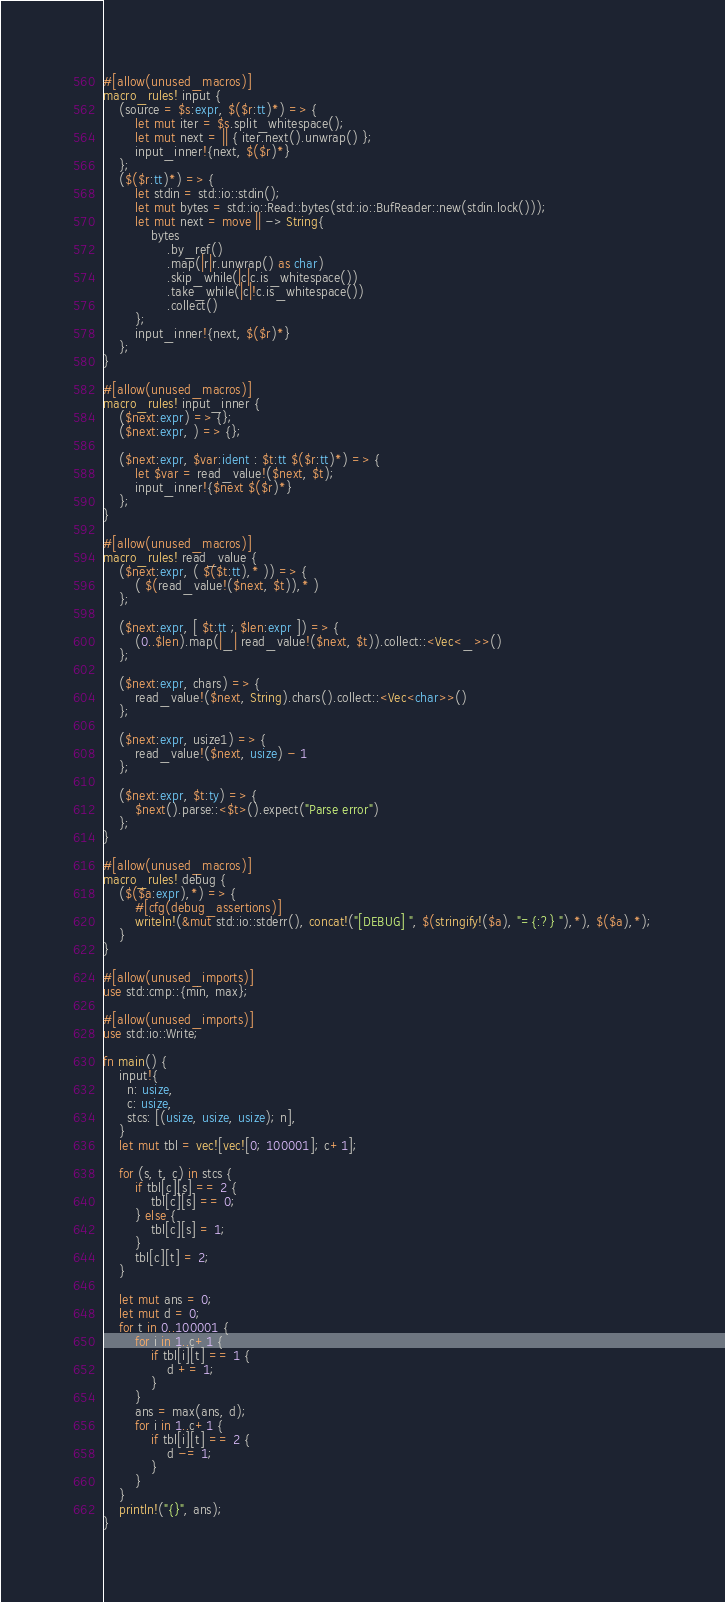Convert code to text. <code><loc_0><loc_0><loc_500><loc_500><_Rust_>#[allow(unused_macros)]
macro_rules! input {
    (source = $s:expr, $($r:tt)*) => {
        let mut iter = $s.split_whitespace();
        let mut next = || { iter.next().unwrap() };
        input_inner!{next, $($r)*}
    };
    ($($r:tt)*) => {
        let stdin = std::io::stdin();
        let mut bytes = std::io::Read::bytes(std::io::BufReader::new(stdin.lock()));
        let mut next = move || -> String{
            bytes
                .by_ref()
                .map(|r|r.unwrap() as char)
                .skip_while(|c|c.is_whitespace())
                .take_while(|c|!c.is_whitespace())
                .collect()
        };
        input_inner!{next, $($r)*}
    };
}

#[allow(unused_macros)]
macro_rules! input_inner {
    ($next:expr) => {};
    ($next:expr, ) => {};

    ($next:expr, $var:ident : $t:tt $($r:tt)*) => {
        let $var = read_value!($next, $t);
        input_inner!{$next $($r)*}
    };
}

#[allow(unused_macros)]
macro_rules! read_value {
    ($next:expr, ( $($t:tt),* )) => {
        ( $(read_value!($next, $t)),* )
    };

    ($next:expr, [ $t:tt ; $len:expr ]) => {
        (0..$len).map(|_| read_value!($next, $t)).collect::<Vec<_>>()
    };

    ($next:expr, chars) => {
        read_value!($next, String).chars().collect::<Vec<char>>()
    };

    ($next:expr, usize1) => {
        read_value!($next, usize) - 1
    };

    ($next:expr, $t:ty) => {
        $next().parse::<$t>().expect("Parse error")
    };
}

#[allow(unused_macros)]
macro_rules! debug {
    ($($a:expr),*) => {
        #[cfg(debug_assertions)]
        writeln!(&mut std::io::stderr(), concat!("[DEBUG] ", $(stringify!($a), "={:?} "),*), $($a),*);
    }
}

#[allow(unused_imports)]
use std::cmp::{min, max};

#[allow(unused_imports)]
use std::io::Write;

fn main() {
    input!{
      n: usize,
      c: usize,
      stcs: [(usize, usize, usize); n],
    }
    let mut tbl = vec![vec![0; 100001]; c+1];

    for (s, t, c) in stcs {
        if tbl[c][s] == 2 {
            tbl[c][s] == 0;
        } else {
            tbl[c][s] = 1;
        }
        tbl[c][t] = 2;
    }

    let mut ans = 0;
    let mut d = 0;
    for t in 0..100001 {
        for i in 1..c+1 {
            if tbl[i][t] == 1 {
                d += 1;
            }
        }
        ans = max(ans, d);
        for i in 1..c+1 {
            if tbl[i][t] == 2 {
                d -= 1;
            }
        }
    }
    println!("{}", ans);
}
</code> 